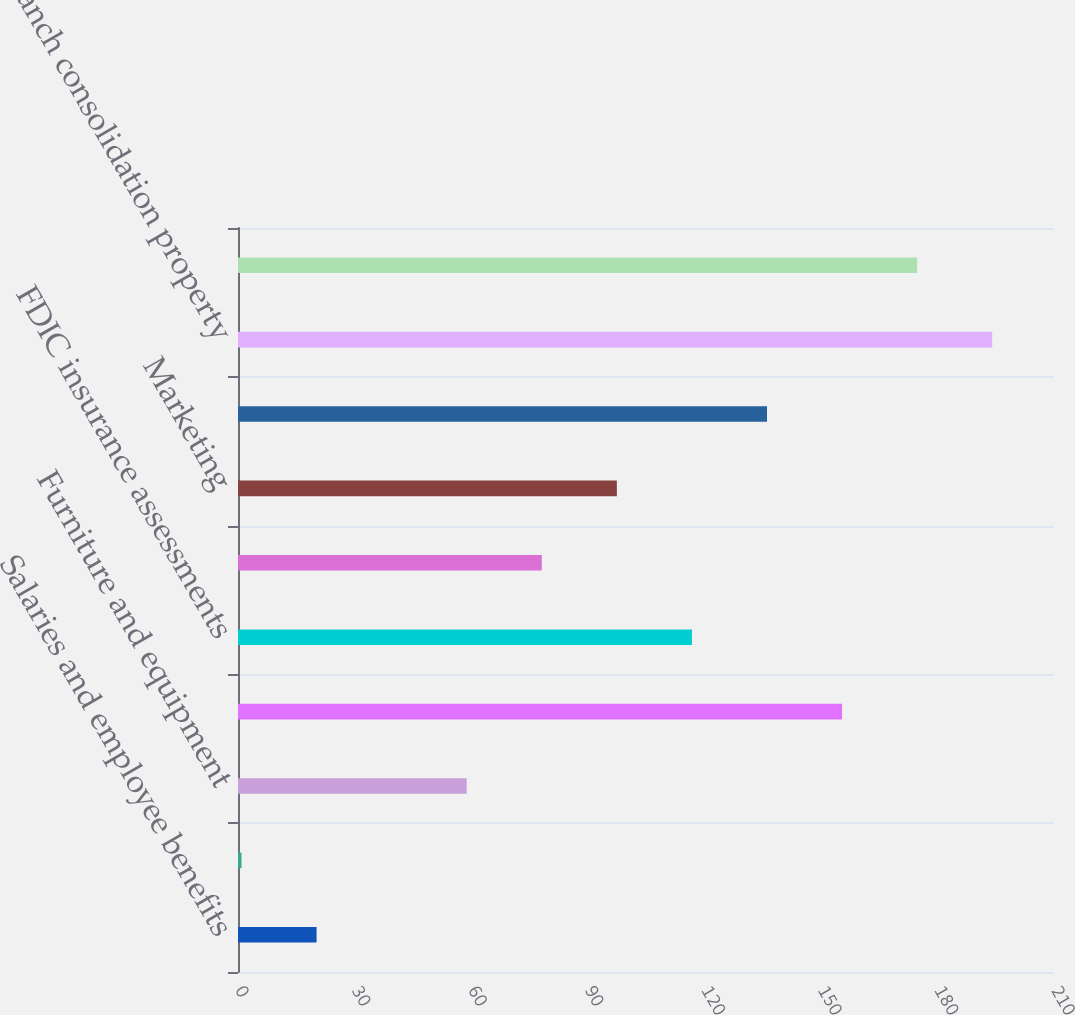Convert chart to OTSL. <chart><loc_0><loc_0><loc_500><loc_500><bar_chart><fcel>Salaries and employee benefits<fcel>Net occupancy expense<fcel>Furniture and equipment<fcel>Outside services<fcel>FDIC insurance assessments<fcel>Professional legal and<fcel>Marketing<fcel>Credit/checkcard expenses<fcel>Branch consolidation property<fcel>Visa class B shares expense<nl><fcel>20.22<fcel>0.9<fcel>58.86<fcel>155.46<fcel>116.82<fcel>78.18<fcel>97.5<fcel>136.14<fcel>194.1<fcel>174.78<nl></chart> 